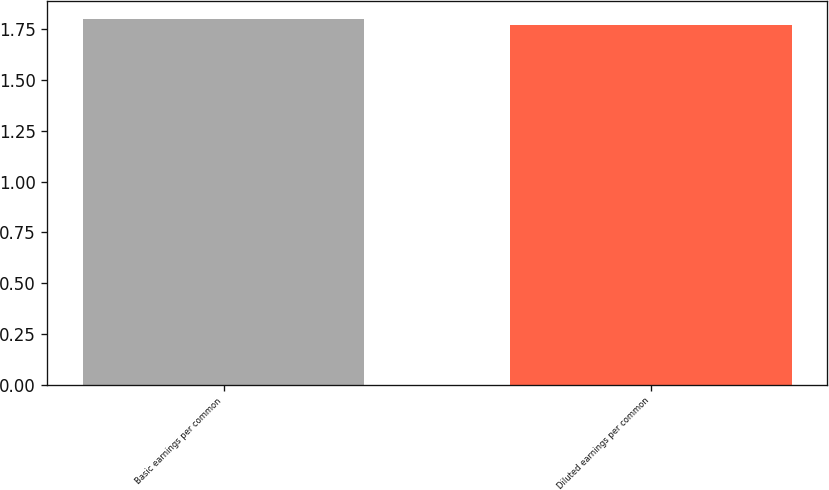<chart> <loc_0><loc_0><loc_500><loc_500><bar_chart><fcel>Basic earnings per common<fcel>Diluted earnings per common<nl><fcel>1.8<fcel>1.77<nl></chart> 